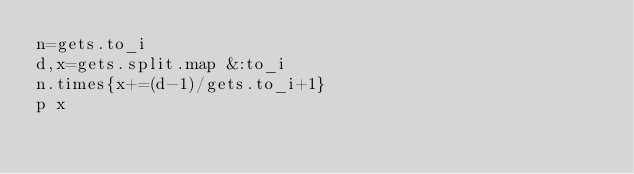<code> <loc_0><loc_0><loc_500><loc_500><_Ruby_>n=gets.to_i
d,x=gets.split.map &:to_i
n.times{x+=(d-1)/gets.to_i+1}
p x</code> 